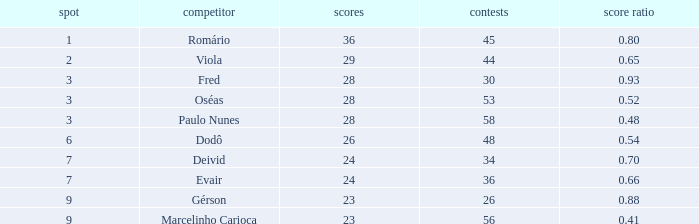How many goal ratios have rank of 2 with more than 44 games? 0.0. 